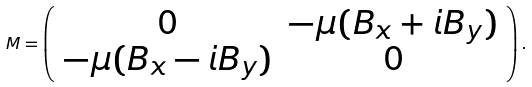<formula> <loc_0><loc_0><loc_500><loc_500>M = \left ( \begin{array} { c c } 0 & - \mu ( B _ { x } + i B _ { y } ) \\ - \mu ( B _ { x } - i B _ { y } ) & 0 \\ \end{array} \right ) .</formula> 